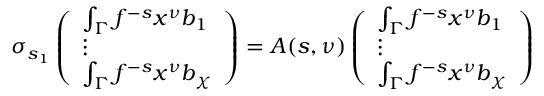Convert formula to latex. <formula><loc_0><loc_0><loc_500><loc_500>\sigma _ { s _ { 1 } } \left ( \begin{array} { l } { \int _ { \Gamma } f ^ { - s } x ^ { \nu } b _ { 1 } } \\ { \vdots } \\ { \int _ { \Gamma } f ^ { - s } x ^ { \nu } b _ { \chi } } \end{array} \right ) = A ( s , \nu ) \left ( \begin{array} { l } { \int _ { \Gamma } f ^ { - s } x ^ { \nu } b _ { 1 } } \\ { \vdots } \\ { \int _ { \Gamma } f ^ { - s } x ^ { \nu } b _ { \chi } } \end{array} \right )</formula> 